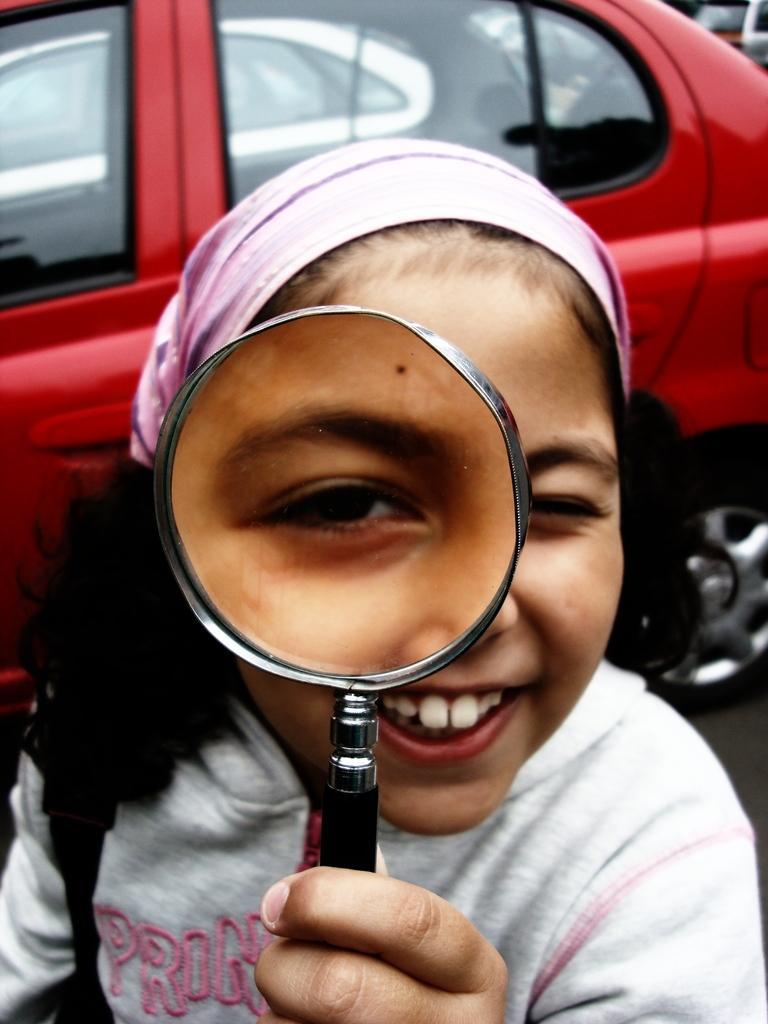In one or two sentences, can you explain what this image depicts? In this image I can see a person standing and holding a magnifying glass in her hand. I can see a red colored car behind her. 